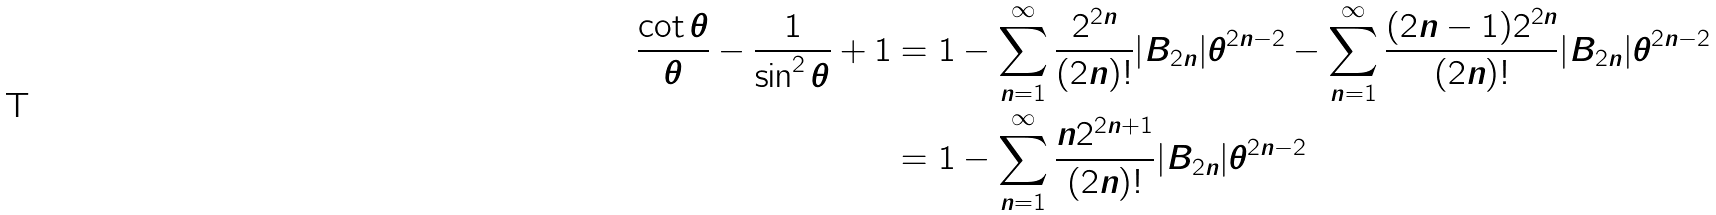Convert formula to latex. <formula><loc_0><loc_0><loc_500><loc_500>\frac { \cot \theta } { \theta } - \frac { 1 } { \sin ^ { 2 } \theta } + 1 & = 1 - \sum _ { n = 1 } ^ { \infty } \frac { 2 ^ { 2 n } } { ( 2 n ) ! } | B _ { 2 n } | \theta ^ { 2 n - 2 } - \sum _ { n = 1 } ^ { \infty } \frac { ( 2 n - 1 ) 2 ^ { 2 n } } { ( 2 n ) ! } | B _ { 2 n } | \theta ^ { 2 n - 2 } \\ & = 1 - \sum _ { n = 1 } ^ { \infty } \frac { n 2 ^ { 2 n + 1 } } { ( 2 n ) ! } | B _ { 2 n } | \theta ^ { 2 n - 2 }</formula> 